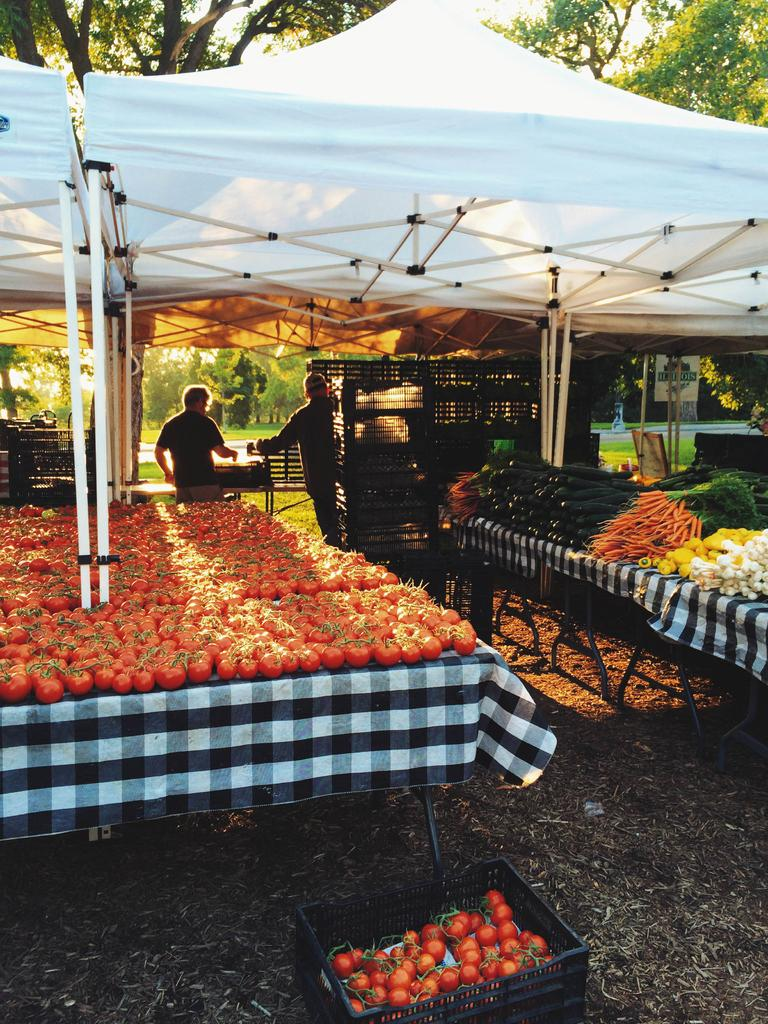How many people are in the image? There are two persons in the image. What is covering the table in the image? There is a tablecloth in the image. What type of food items can be seen in the image? Vegetables are present in the image. What object is used for carrying or holding items in the image? There is a basket in the image. What surface is visible in the image? A board is visible in the image. What type of temporary shelter is present in the image? There is a tent in the image. What type of ground surface is visible in the image? The ground is covered with grass. What can be seen in the background of the image? There are trees in the background of the image. Can you see a family swimming in the lake in the image? There is no lake or family swimming in the image. What type of coat is hanging on the tent in the image? There is no coat present in the image. 